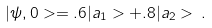<formula> <loc_0><loc_0><loc_500><loc_500>| \psi , 0 > = . 6 | a _ { 1 } > + . 8 | a _ { 2 } > \, .</formula> 